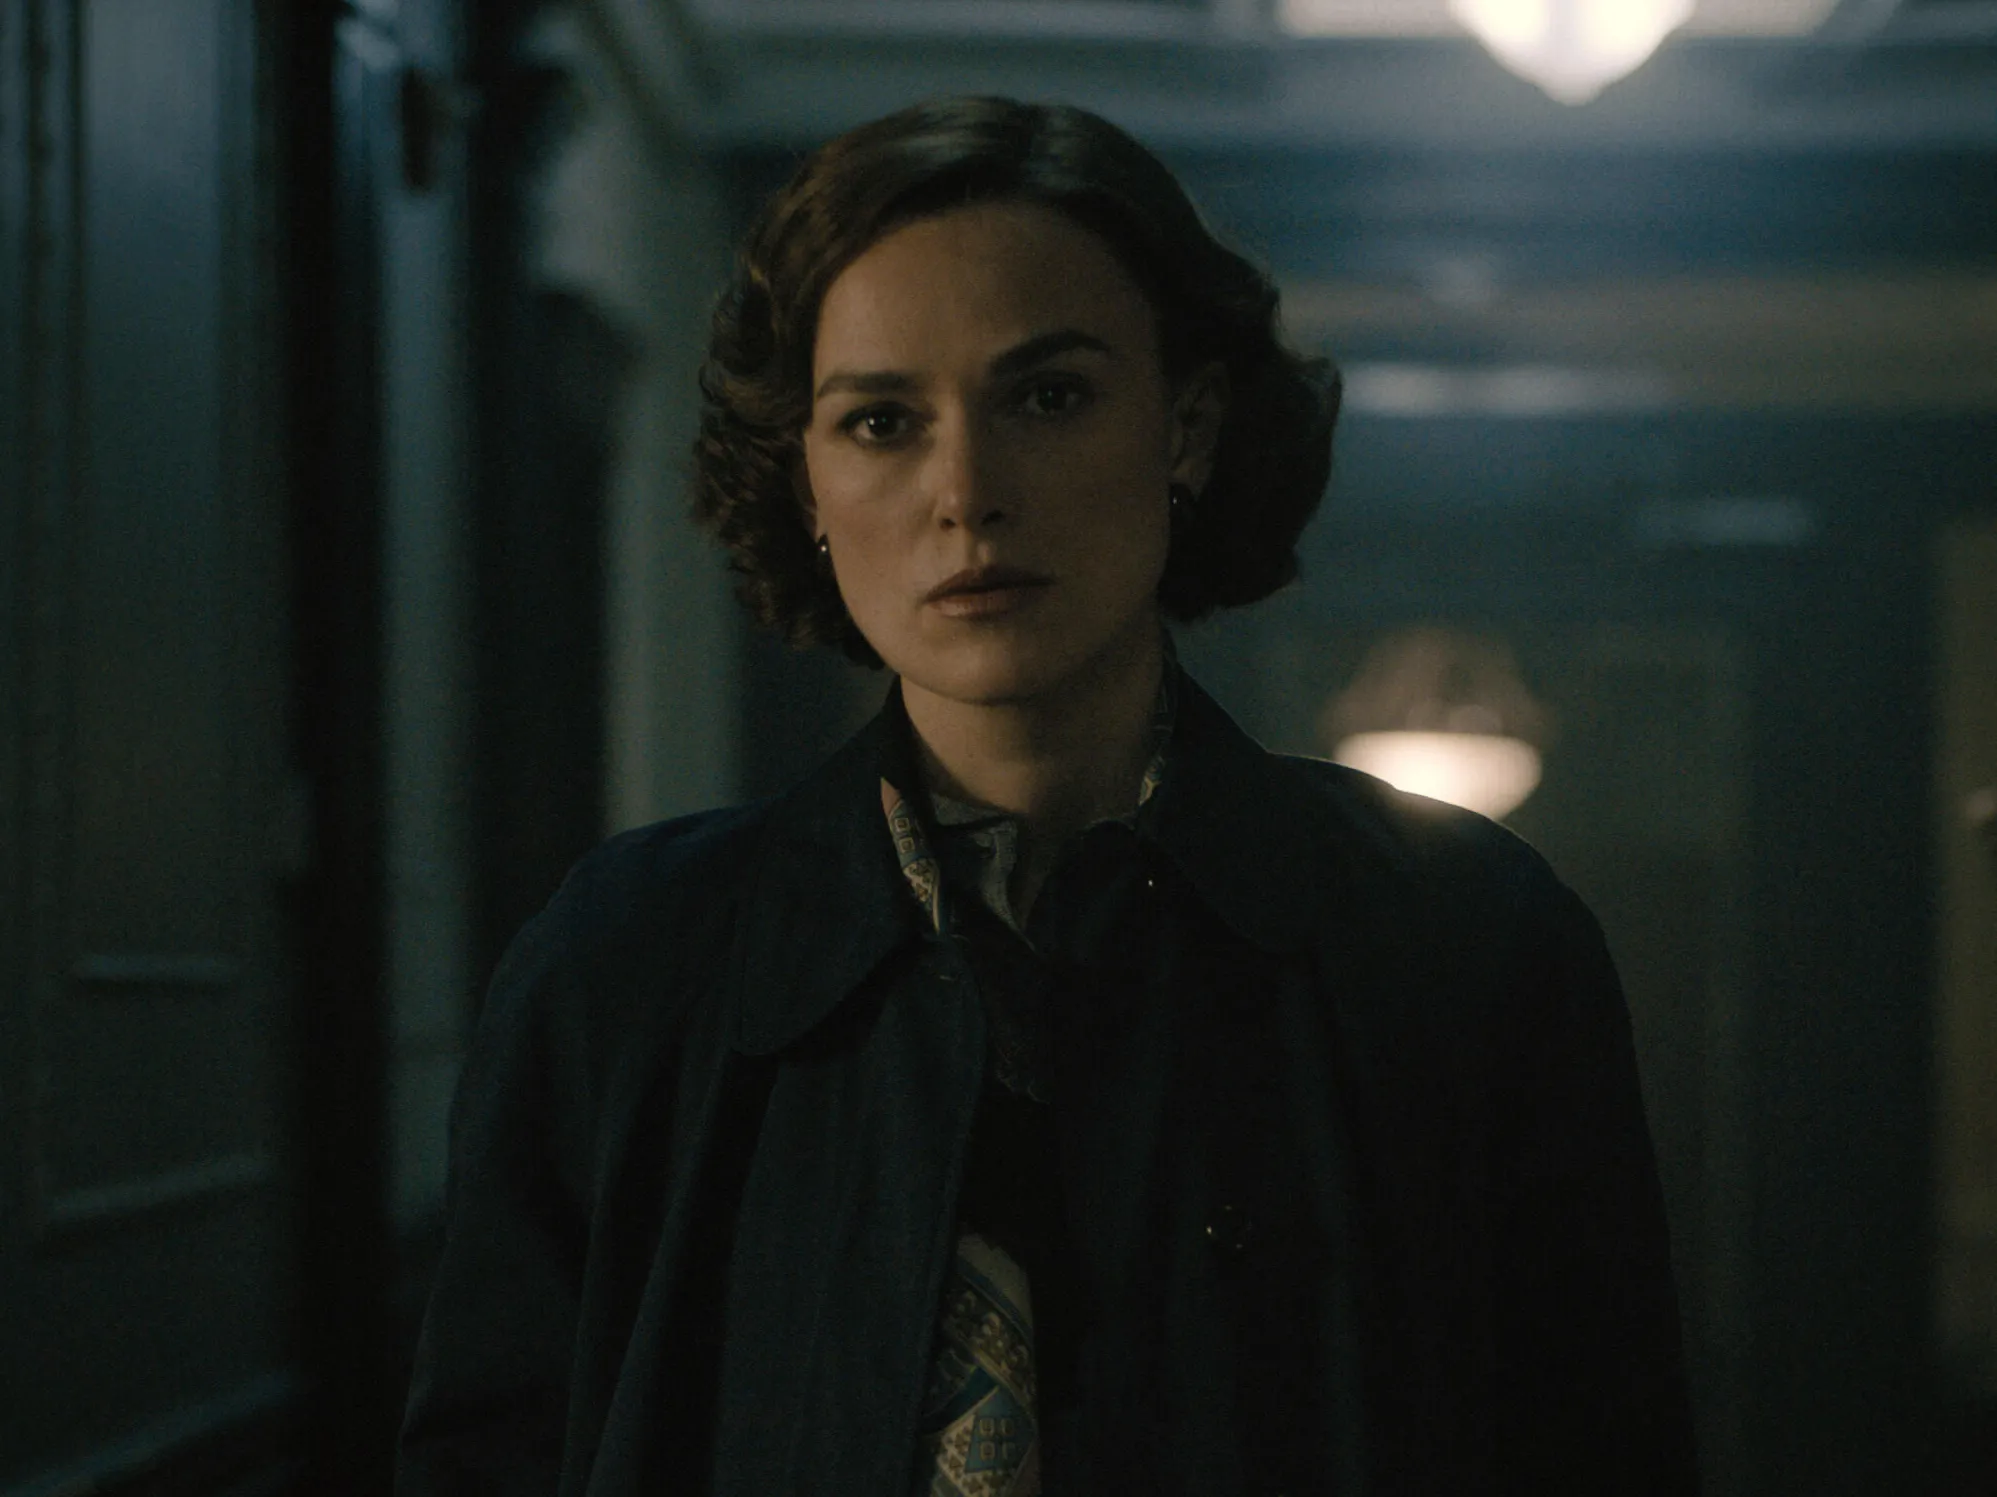Describe a realistic scenario for this image in a short way. The woman is a detective investigating a crime in an old mansion. Deep in thought, she considers the clues she's found, the dim hallway adding to the mystery of her investigation.  Describe another realistic scenario in a long way. In this realistic scenario, the woman is a journalist during the 1940s, investigating a high-profile espionage case. She's infiltrating a renowned politician's residence under the cover of darkness, hoping to uncover evidence of their involvement in a series of illegal activities. The hallways, dimly lit and eerily quiet, amplify her anxiety as she moves stealthily from room to room. Her serious expression shows the weight of the risk she's taking, knowing that any misstep could lead to her discovery and possible imprisonment. The gravity of her assignment, combined with the historical backdrop of war-time secrecy, paints a compelling, tension-filled narrative. 